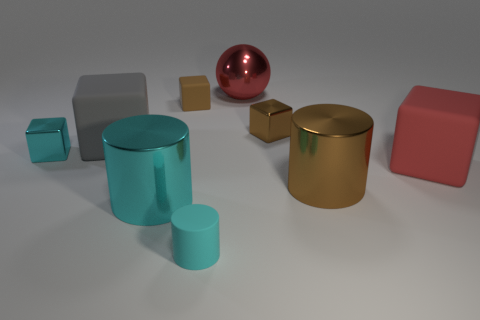What materials do the objects in the image seem to be made of? The objects in the image appear to have surfaces that reflect light differently, suggesting a variety of materials. Some appear metallic with a high gloss, while others have a matte finish that might be indicative of plastic or a painted surface. 